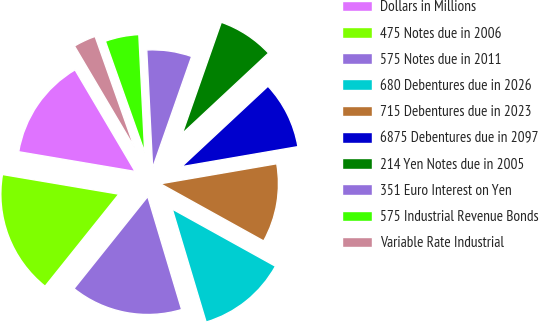<chart> <loc_0><loc_0><loc_500><loc_500><pie_chart><fcel>Dollars in Millions<fcel>475 Notes due in 2006<fcel>575 Notes due in 2011<fcel>680 Debentures due in 2026<fcel>715 Debentures due in 2023<fcel>6875 Debentures due in 2097<fcel>214 Yen Notes due in 2005<fcel>351 Euro Interest on Yen<fcel>575 Industrial Revenue Bonds<fcel>Variable Rate Industrial<nl><fcel>13.84%<fcel>16.92%<fcel>15.38%<fcel>12.31%<fcel>10.77%<fcel>9.23%<fcel>7.69%<fcel>6.16%<fcel>4.62%<fcel>3.08%<nl></chart> 